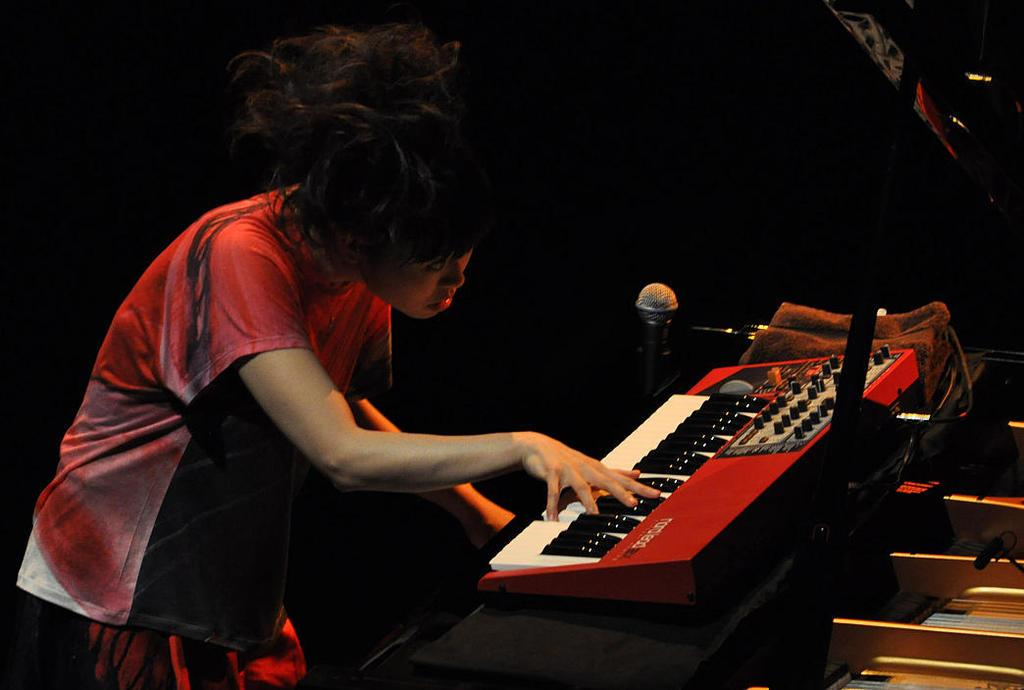Who is the main subject in the image? There is a woman in the image. What is the woman doing in the image? The woman is standing and playing a musical keyboard. What object is present in the image that is typically used for amplifying sound? There is a microphone in the image. How would you describe the lighting in the image? The background of the image is dark. What type of lamp is visible on the musical keyboard in the image? There is no lamp present on the musical keyboard in the image. What event is the woman attending in the image? The image does not provide any information about an event; it simply shows a woman playing a musical keyboard. 